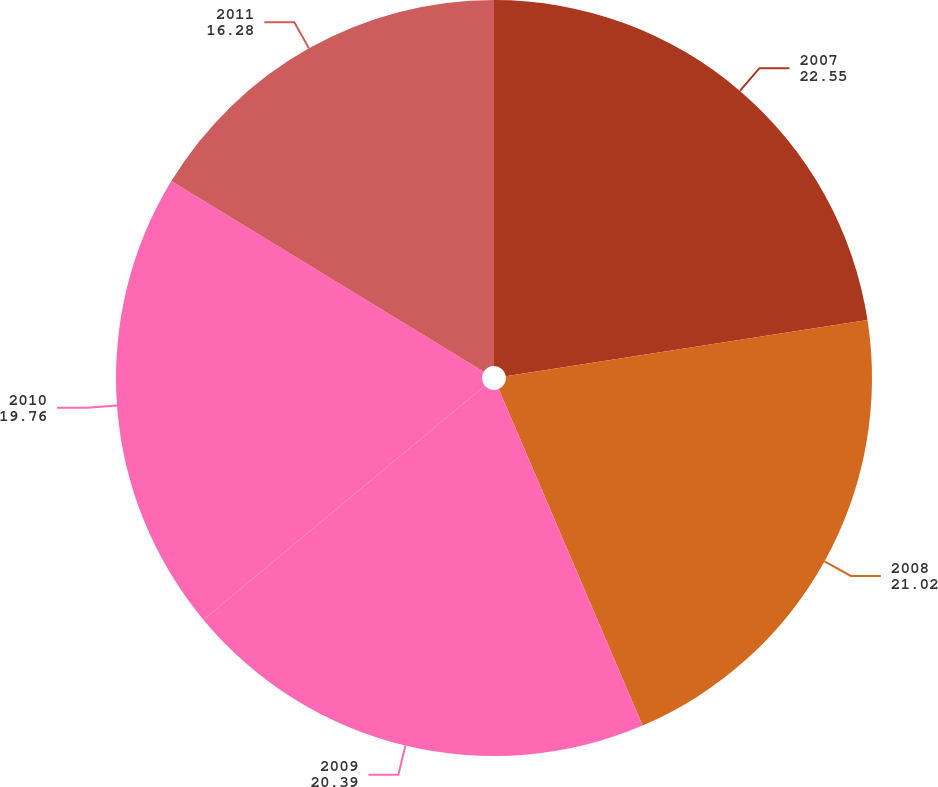Convert chart. <chart><loc_0><loc_0><loc_500><loc_500><pie_chart><fcel>2007<fcel>2008<fcel>2009<fcel>2010<fcel>2011<nl><fcel>22.55%<fcel>21.02%<fcel>20.39%<fcel>19.76%<fcel>16.28%<nl></chart> 